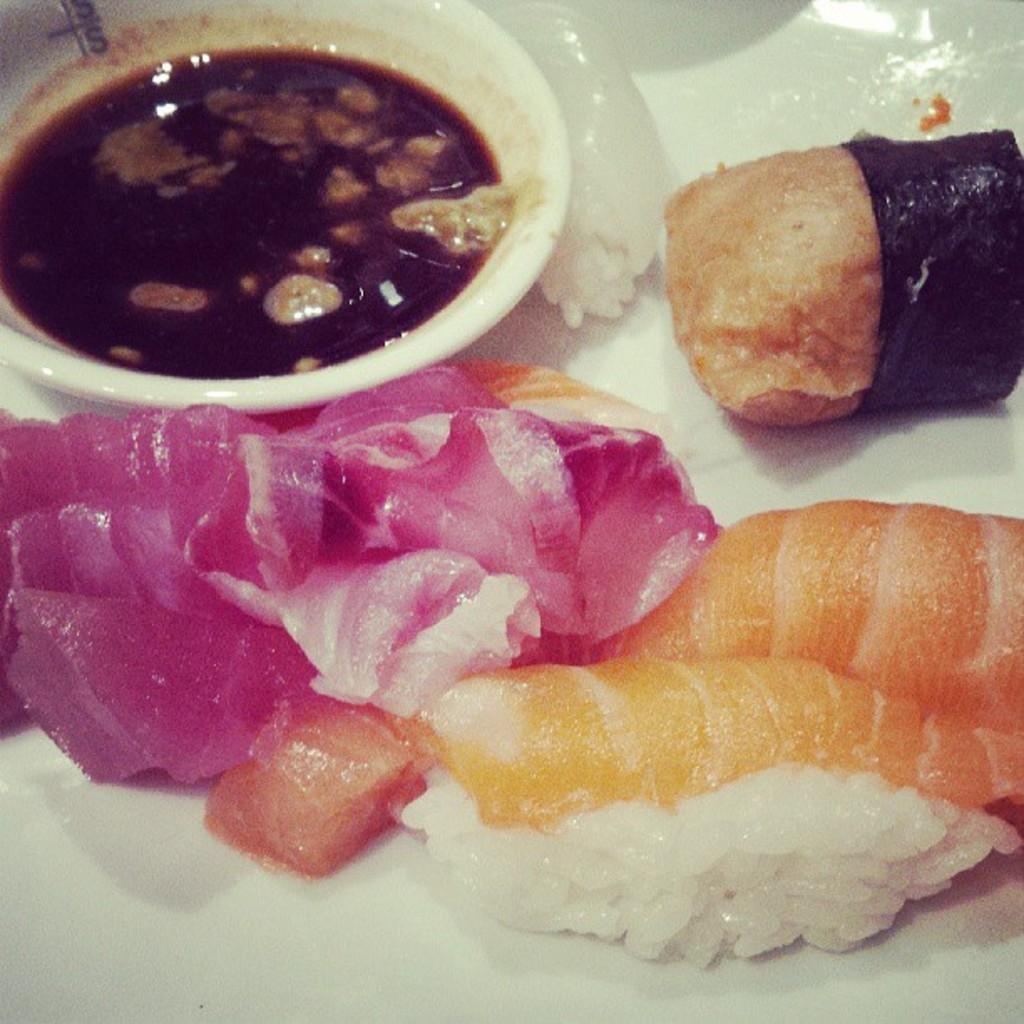What is on the plate in the image? There is food on the plate in the image. What else can be seen in the image besides the plate? There is a bowl with sauce in the image. What type of music can be heard playing in the background of the image? There is no music or sound present in the image, as it is a still photograph. 